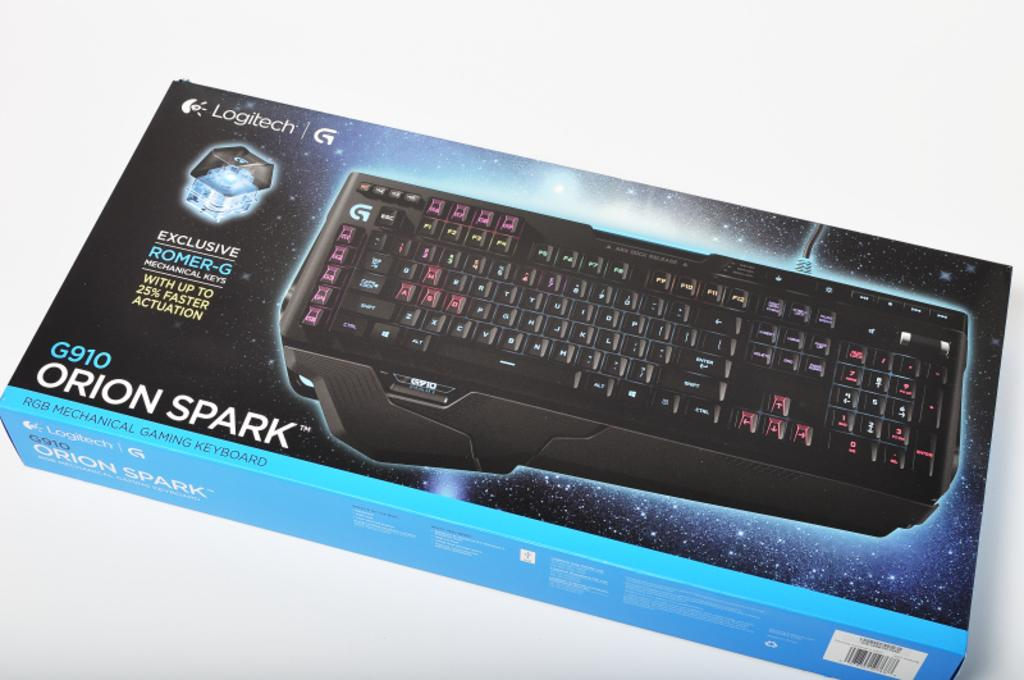<image>
Render a clear and concise summary of the photo. An Orion Spark mechanical gaming keyboard from Logitech still in the box. 